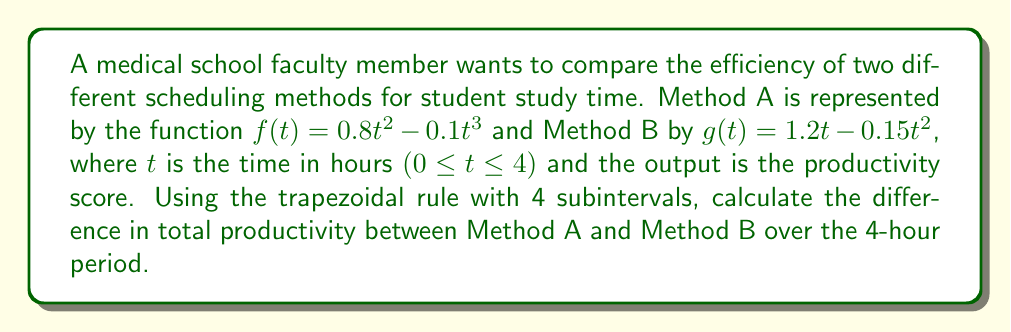Show me your answer to this math problem. To solve this problem, we need to use numerical integration with the trapezoidal rule for both methods and then compare the results.

Step 1: Set up the trapezoidal rule for 4 subintervals.
The trapezoidal rule formula is:

$$\int_{a}^{b} f(x) dx \approx \frac{h}{2}[f(x_0) + 2f(x_1) + 2f(x_2) + 2f(x_3) + f(x_4)]$$

Where $h = \frac{b-a}{n}$, $n$ is the number of subintervals, and $x_i = a + ih$.

Step 2: Calculate h and the x values.
$h = \frac{4-0}{4} = 1$
$x_0 = 0, x_1 = 1, x_2 = 2, x_3 = 3, x_4 = 4$

Step 3: Calculate the function values for Method A.
$f(0) = 0$
$f(1) = 0.8(1)^2 - 0.1(1)^3 = 0.7$
$f(2) = 0.8(2)^2 - 0.1(2)^3 = 2.4$
$f(3) = 0.8(3)^2 - 0.1(3)^3 = 4.5$
$f(4) = 0.8(4)^2 - 0.1(4)^3 = 6.4$

Step 4: Apply the trapezoidal rule for Method A.
$$\int_{0}^{4} f(t) dt \approx \frac{1}{2}[0 + 2(0.7) + 2(2.4) + 2(4.5) + 6.4] = 10.8$$

Step 5: Calculate the function values for Method B.
$g(0) = 0$
$g(1) = 1.2(1) - 0.15(1)^2 = 1.05$
$g(2) = 1.2(2) - 0.15(2)^2 = 1.8$
$g(3) = 1.2(3) - 0.15(3)^2 = 2.25$
$g(4) = 1.2(4) - 0.15(4)^2 = 2.4$

Step 6: Apply the trapezoidal rule for Method B.
$$\int_{0}^{4} g(t) dt \approx \frac{1}{2}[0 + 2(1.05) + 2(1.8) + 2(2.25) + 2.4] = 7.5$$

Step 7: Calculate the difference in total productivity.
Difference = Method A - Method B = 10.8 - 7.5 = 3.3
Answer: 3.3 